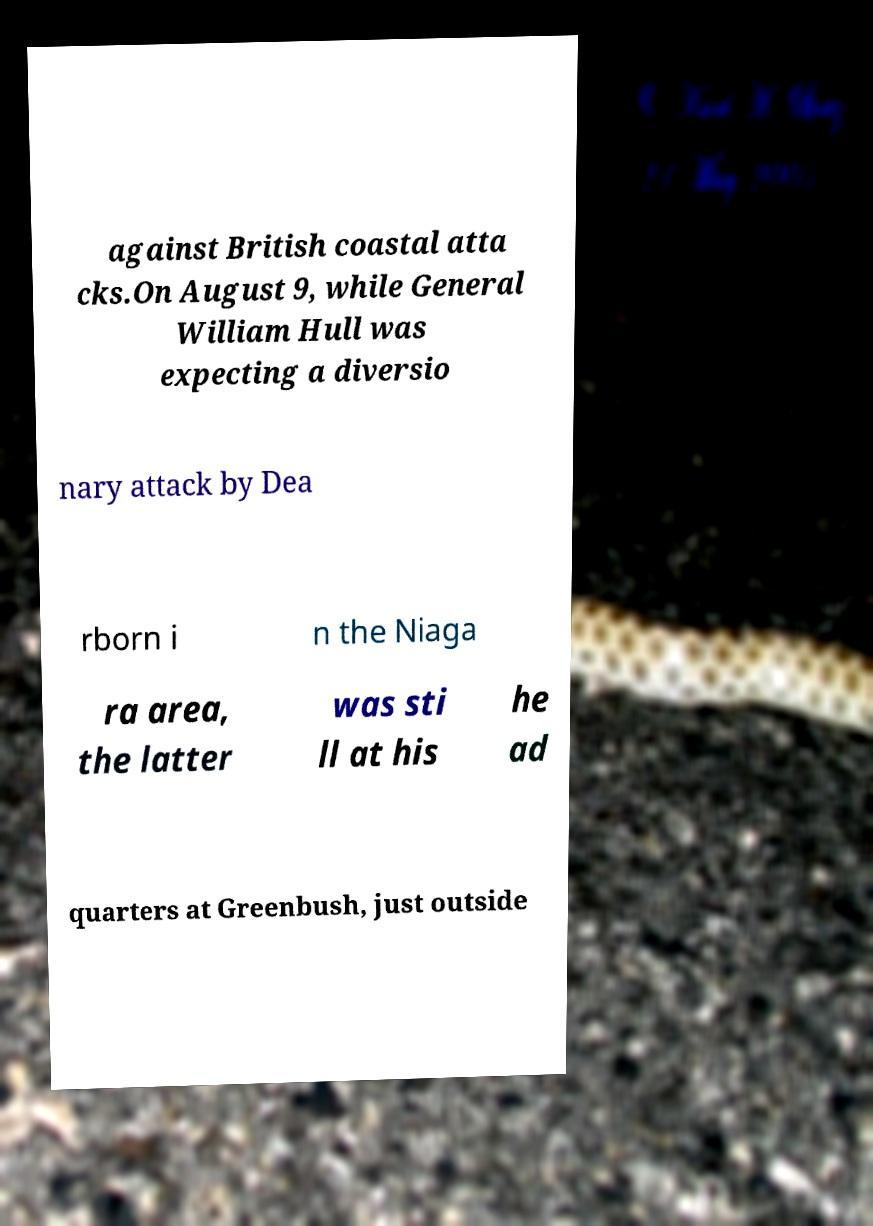Could you assist in decoding the text presented in this image and type it out clearly? against British coastal atta cks.On August 9, while General William Hull was expecting a diversio nary attack by Dea rborn i n the Niaga ra area, the latter was sti ll at his he ad quarters at Greenbush, just outside 